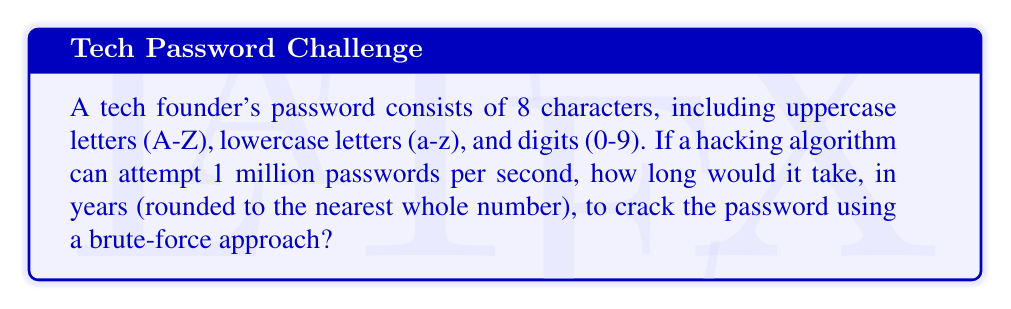Give your solution to this math problem. To solve this problem, we'll follow these steps:

1. Calculate the total number of possible passwords:
   - Uppercase letters: 26
   - Lowercase letters: 26
   - Digits: 10
   - Total characters: 26 + 26 + 10 = 62
   - Password length: 8
   - Total combinations: $62^8$

2. Calculate the number of attempts per year:
   - Attempts per second: 1,000,000
   - Seconds in a year: 365 * 24 * 60 * 60 = 31,536,000

3. Calculate the time required to try all combinations:
   Let $T$ be the time in years.

   $$T = \frac{62^8}{1,000,000 * 31,536,000}$$

4. Simplify and calculate:
   $$T = \frac{62^8}{3.1536 * 10^{13}}$$
   $$T \approx 218.34 \text{ years}$$

5. Round to the nearest whole number:
   218 years
Answer: 218 years 